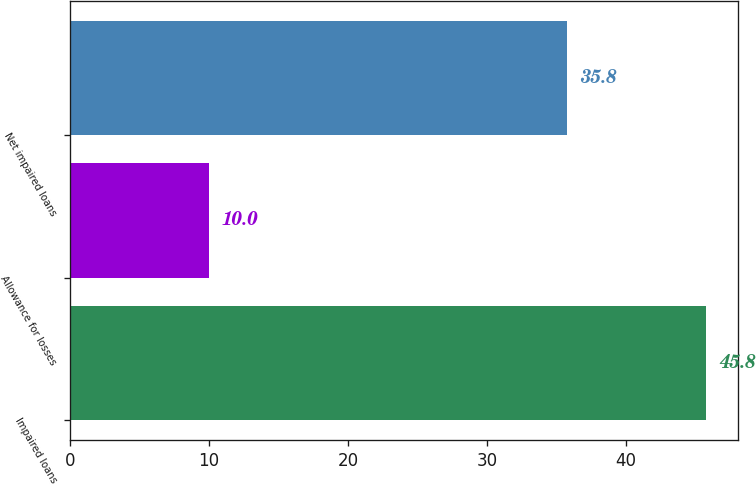Convert chart. <chart><loc_0><loc_0><loc_500><loc_500><bar_chart><fcel>Impaired loans<fcel>Allowance for losses<fcel>Net impaired loans<nl><fcel>45.8<fcel>10<fcel>35.8<nl></chart> 